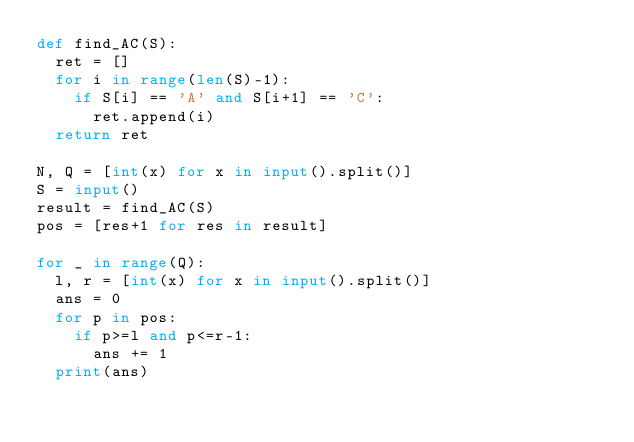<code> <loc_0><loc_0><loc_500><loc_500><_Python_>def find_AC(S):
  ret = []
  for i in range(len(S)-1):
    if S[i] == 'A' and S[i+1] == 'C':
      ret.append(i)
  return ret

N, Q = [int(x) for x in input().split()]
S = input()
result = find_AC(S)
pos = [res+1 for res in result]

for _ in range(Q):
  l, r = [int(x) for x in input().split()]
  ans = 0
  for p in pos:
    if p>=l and p<=r-1:
      ans += 1
  print(ans)
</code> 